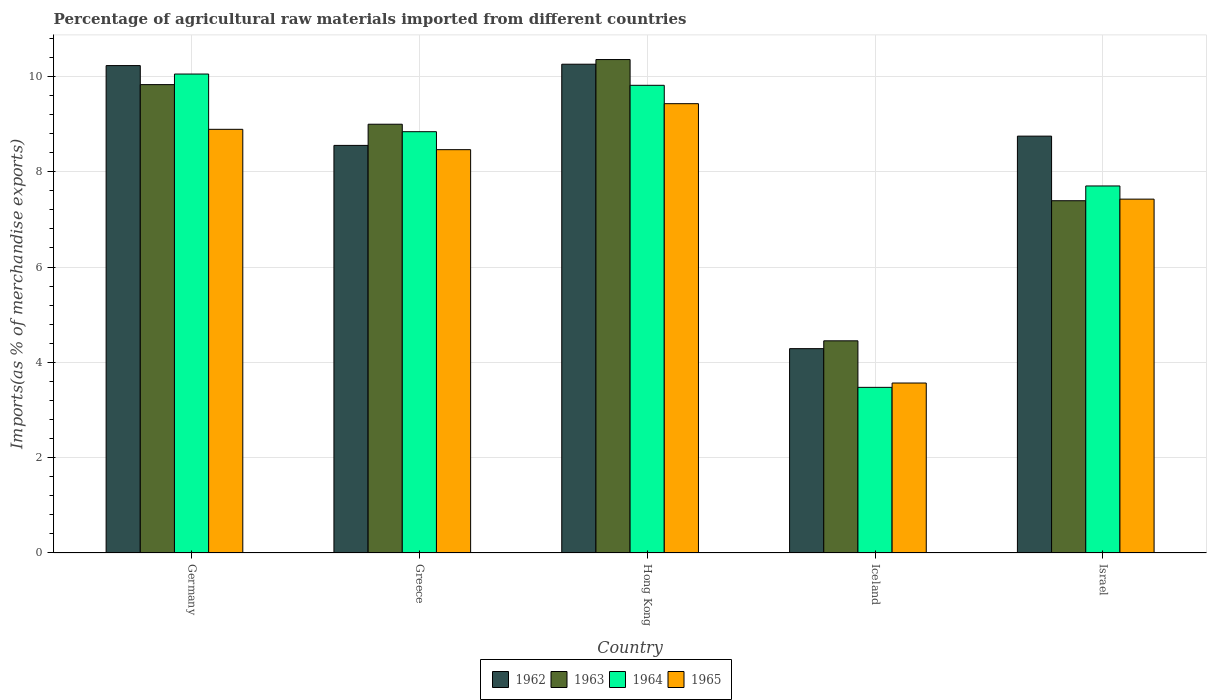How many different coloured bars are there?
Give a very brief answer. 4. How many groups of bars are there?
Give a very brief answer. 5. Are the number of bars per tick equal to the number of legend labels?
Provide a succinct answer. Yes. How many bars are there on the 4th tick from the right?
Make the answer very short. 4. What is the label of the 3rd group of bars from the left?
Offer a terse response. Hong Kong. In how many cases, is the number of bars for a given country not equal to the number of legend labels?
Your response must be concise. 0. What is the percentage of imports to different countries in 1962 in Greece?
Offer a very short reply. 8.55. Across all countries, what is the maximum percentage of imports to different countries in 1965?
Your response must be concise. 9.43. Across all countries, what is the minimum percentage of imports to different countries in 1963?
Offer a terse response. 4.45. In which country was the percentage of imports to different countries in 1965 maximum?
Your response must be concise. Hong Kong. What is the total percentage of imports to different countries in 1965 in the graph?
Your answer should be very brief. 37.77. What is the difference between the percentage of imports to different countries in 1965 in Germany and that in Israel?
Offer a terse response. 1.46. What is the difference between the percentage of imports to different countries in 1963 in Germany and the percentage of imports to different countries in 1965 in Israel?
Provide a short and direct response. 2.4. What is the average percentage of imports to different countries in 1965 per country?
Keep it short and to the point. 7.55. What is the difference between the percentage of imports to different countries of/in 1962 and percentage of imports to different countries of/in 1964 in Iceland?
Keep it short and to the point. 0.81. What is the ratio of the percentage of imports to different countries in 1963 in Hong Kong to that in Israel?
Offer a terse response. 1.4. What is the difference between the highest and the second highest percentage of imports to different countries in 1964?
Offer a very short reply. -0.97. What is the difference between the highest and the lowest percentage of imports to different countries in 1963?
Give a very brief answer. 5.9. Is it the case that in every country, the sum of the percentage of imports to different countries in 1964 and percentage of imports to different countries in 1965 is greater than the sum of percentage of imports to different countries in 1962 and percentage of imports to different countries in 1963?
Keep it short and to the point. No. What does the 3rd bar from the left in Greece represents?
Give a very brief answer. 1964. How many bars are there?
Provide a succinct answer. 20. Are all the bars in the graph horizontal?
Provide a succinct answer. No. Are the values on the major ticks of Y-axis written in scientific E-notation?
Ensure brevity in your answer.  No. Does the graph contain grids?
Offer a terse response. Yes. Where does the legend appear in the graph?
Ensure brevity in your answer.  Bottom center. What is the title of the graph?
Make the answer very short. Percentage of agricultural raw materials imported from different countries. Does "1991" appear as one of the legend labels in the graph?
Provide a short and direct response. No. What is the label or title of the Y-axis?
Your answer should be very brief. Imports(as % of merchandise exports). What is the Imports(as % of merchandise exports) of 1962 in Germany?
Give a very brief answer. 10.23. What is the Imports(as % of merchandise exports) of 1963 in Germany?
Offer a very short reply. 9.83. What is the Imports(as % of merchandise exports) of 1964 in Germany?
Your answer should be very brief. 10.05. What is the Imports(as % of merchandise exports) in 1965 in Germany?
Provide a short and direct response. 8.89. What is the Imports(as % of merchandise exports) of 1962 in Greece?
Provide a succinct answer. 8.55. What is the Imports(as % of merchandise exports) of 1963 in Greece?
Provide a short and direct response. 9. What is the Imports(as % of merchandise exports) of 1964 in Greece?
Make the answer very short. 8.84. What is the Imports(as % of merchandise exports) in 1965 in Greece?
Offer a terse response. 8.46. What is the Imports(as % of merchandise exports) of 1962 in Hong Kong?
Your answer should be very brief. 10.26. What is the Imports(as % of merchandise exports) in 1963 in Hong Kong?
Keep it short and to the point. 10.35. What is the Imports(as % of merchandise exports) of 1964 in Hong Kong?
Offer a terse response. 9.81. What is the Imports(as % of merchandise exports) in 1965 in Hong Kong?
Your answer should be very brief. 9.43. What is the Imports(as % of merchandise exports) in 1962 in Iceland?
Your answer should be compact. 4.29. What is the Imports(as % of merchandise exports) in 1963 in Iceland?
Give a very brief answer. 4.45. What is the Imports(as % of merchandise exports) in 1964 in Iceland?
Provide a short and direct response. 3.48. What is the Imports(as % of merchandise exports) in 1965 in Iceland?
Your answer should be very brief. 3.57. What is the Imports(as % of merchandise exports) of 1962 in Israel?
Your answer should be compact. 8.75. What is the Imports(as % of merchandise exports) in 1963 in Israel?
Give a very brief answer. 7.39. What is the Imports(as % of merchandise exports) of 1964 in Israel?
Make the answer very short. 7.7. What is the Imports(as % of merchandise exports) in 1965 in Israel?
Offer a terse response. 7.42. Across all countries, what is the maximum Imports(as % of merchandise exports) of 1962?
Make the answer very short. 10.26. Across all countries, what is the maximum Imports(as % of merchandise exports) of 1963?
Your answer should be compact. 10.35. Across all countries, what is the maximum Imports(as % of merchandise exports) in 1964?
Give a very brief answer. 10.05. Across all countries, what is the maximum Imports(as % of merchandise exports) in 1965?
Offer a very short reply. 9.43. Across all countries, what is the minimum Imports(as % of merchandise exports) of 1962?
Your answer should be compact. 4.29. Across all countries, what is the minimum Imports(as % of merchandise exports) of 1963?
Offer a terse response. 4.45. Across all countries, what is the minimum Imports(as % of merchandise exports) of 1964?
Your answer should be very brief. 3.48. Across all countries, what is the minimum Imports(as % of merchandise exports) in 1965?
Make the answer very short. 3.57. What is the total Imports(as % of merchandise exports) of 1962 in the graph?
Keep it short and to the point. 42.07. What is the total Imports(as % of merchandise exports) in 1963 in the graph?
Ensure brevity in your answer.  41.02. What is the total Imports(as % of merchandise exports) of 1964 in the graph?
Keep it short and to the point. 39.88. What is the total Imports(as % of merchandise exports) of 1965 in the graph?
Give a very brief answer. 37.77. What is the difference between the Imports(as % of merchandise exports) of 1962 in Germany and that in Greece?
Make the answer very short. 1.67. What is the difference between the Imports(as % of merchandise exports) of 1963 in Germany and that in Greece?
Your response must be concise. 0.83. What is the difference between the Imports(as % of merchandise exports) of 1964 in Germany and that in Greece?
Your response must be concise. 1.21. What is the difference between the Imports(as % of merchandise exports) of 1965 in Germany and that in Greece?
Offer a terse response. 0.43. What is the difference between the Imports(as % of merchandise exports) of 1962 in Germany and that in Hong Kong?
Give a very brief answer. -0.03. What is the difference between the Imports(as % of merchandise exports) of 1963 in Germany and that in Hong Kong?
Make the answer very short. -0.53. What is the difference between the Imports(as % of merchandise exports) in 1964 in Germany and that in Hong Kong?
Your response must be concise. 0.24. What is the difference between the Imports(as % of merchandise exports) of 1965 in Germany and that in Hong Kong?
Offer a terse response. -0.54. What is the difference between the Imports(as % of merchandise exports) in 1962 in Germany and that in Iceland?
Offer a very short reply. 5.94. What is the difference between the Imports(as % of merchandise exports) of 1963 in Germany and that in Iceland?
Offer a very short reply. 5.38. What is the difference between the Imports(as % of merchandise exports) of 1964 in Germany and that in Iceland?
Make the answer very short. 6.57. What is the difference between the Imports(as % of merchandise exports) of 1965 in Germany and that in Iceland?
Ensure brevity in your answer.  5.32. What is the difference between the Imports(as % of merchandise exports) of 1962 in Germany and that in Israel?
Provide a succinct answer. 1.48. What is the difference between the Imports(as % of merchandise exports) of 1963 in Germany and that in Israel?
Offer a very short reply. 2.44. What is the difference between the Imports(as % of merchandise exports) in 1964 in Germany and that in Israel?
Provide a succinct answer. 2.35. What is the difference between the Imports(as % of merchandise exports) in 1965 in Germany and that in Israel?
Your answer should be very brief. 1.46. What is the difference between the Imports(as % of merchandise exports) of 1962 in Greece and that in Hong Kong?
Your response must be concise. -1.7. What is the difference between the Imports(as % of merchandise exports) in 1963 in Greece and that in Hong Kong?
Offer a terse response. -1.36. What is the difference between the Imports(as % of merchandise exports) in 1964 in Greece and that in Hong Kong?
Your answer should be compact. -0.97. What is the difference between the Imports(as % of merchandise exports) in 1965 in Greece and that in Hong Kong?
Your answer should be compact. -0.96. What is the difference between the Imports(as % of merchandise exports) in 1962 in Greece and that in Iceland?
Ensure brevity in your answer.  4.26. What is the difference between the Imports(as % of merchandise exports) in 1963 in Greece and that in Iceland?
Keep it short and to the point. 4.54. What is the difference between the Imports(as % of merchandise exports) of 1964 in Greece and that in Iceland?
Your answer should be compact. 5.36. What is the difference between the Imports(as % of merchandise exports) of 1965 in Greece and that in Iceland?
Give a very brief answer. 4.9. What is the difference between the Imports(as % of merchandise exports) of 1962 in Greece and that in Israel?
Your answer should be very brief. -0.19. What is the difference between the Imports(as % of merchandise exports) in 1963 in Greece and that in Israel?
Provide a short and direct response. 1.6. What is the difference between the Imports(as % of merchandise exports) in 1964 in Greece and that in Israel?
Provide a succinct answer. 1.14. What is the difference between the Imports(as % of merchandise exports) in 1965 in Greece and that in Israel?
Your answer should be compact. 1.04. What is the difference between the Imports(as % of merchandise exports) of 1962 in Hong Kong and that in Iceland?
Provide a short and direct response. 5.97. What is the difference between the Imports(as % of merchandise exports) of 1963 in Hong Kong and that in Iceland?
Make the answer very short. 5.9. What is the difference between the Imports(as % of merchandise exports) of 1964 in Hong Kong and that in Iceland?
Your answer should be compact. 6.34. What is the difference between the Imports(as % of merchandise exports) in 1965 in Hong Kong and that in Iceland?
Give a very brief answer. 5.86. What is the difference between the Imports(as % of merchandise exports) in 1962 in Hong Kong and that in Israel?
Your answer should be very brief. 1.51. What is the difference between the Imports(as % of merchandise exports) in 1963 in Hong Kong and that in Israel?
Your answer should be compact. 2.96. What is the difference between the Imports(as % of merchandise exports) in 1964 in Hong Kong and that in Israel?
Offer a very short reply. 2.11. What is the difference between the Imports(as % of merchandise exports) of 1965 in Hong Kong and that in Israel?
Make the answer very short. 2. What is the difference between the Imports(as % of merchandise exports) of 1962 in Iceland and that in Israel?
Provide a short and direct response. -4.46. What is the difference between the Imports(as % of merchandise exports) of 1963 in Iceland and that in Israel?
Your answer should be compact. -2.94. What is the difference between the Imports(as % of merchandise exports) in 1964 in Iceland and that in Israel?
Offer a terse response. -4.23. What is the difference between the Imports(as % of merchandise exports) of 1965 in Iceland and that in Israel?
Provide a succinct answer. -3.86. What is the difference between the Imports(as % of merchandise exports) of 1962 in Germany and the Imports(as % of merchandise exports) of 1963 in Greece?
Your response must be concise. 1.23. What is the difference between the Imports(as % of merchandise exports) of 1962 in Germany and the Imports(as % of merchandise exports) of 1964 in Greece?
Make the answer very short. 1.39. What is the difference between the Imports(as % of merchandise exports) in 1962 in Germany and the Imports(as % of merchandise exports) in 1965 in Greece?
Your answer should be compact. 1.76. What is the difference between the Imports(as % of merchandise exports) of 1963 in Germany and the Imports(as % of merchandise exports) of 1964 in Greece?
Ensure brevity in your answer.  0.99. What is the difference between the Imports(as % of merchandise exports) in 1963 in Germany and the Imports(as % of merchandise exports) in 1965 in Greece?
Make the answer very short. 1.36. What is the difference between the Imports(as % of merchandise exports) of 1964 in Germany and the Imports(as % of merchandise exports) of 1965 in Greece?
Make the answer very short. 1.59. What is the difference between the Imports(as % of merchandise exports) of 1962 in Germany and the Imports(as % of merchandise exports) of 1963 in Hong Kong?
Your answer should be very brief. -0.13. What is the difference between the Imports(as % of merchandise exports) in 1962 in Germany and the Imports(as % of merchandise exports) in 1964 in Hong Kong?
Offer a very short reply. 0.41. What is the difference between the Imports(as % of merchandise exports) of 1962 in Germany and the Imports(as % of merchandise exports) of 1965 in Hong Kong?
Offer a terse response. 0.8. What is the difference between the Imports(as % of merchandise exports) in 1963 in Germany and the Imports(as % of merchandise exports) in 1964 in Hong Kong?
Give a very brief answer. 0.01. What is the difference between the Imports(as % of merchandise exports) of 1963 in Germany and the Imports(as % of merchandise exports) of 1965 in Hong Kong?
Provide a succinct answer. 0.4. What is the difference between the Imports(as % of merchandise exports) of 1964 in Germany and the Imports(as % of merchandise exports) of 1965 in Hong Kong?
Your response must be concise. 0.62. What is the difference between the Imports(as % of merchandise exports) of 1962 in Germany and the Imports(as % of merchandise exports) of 1963 in Iceland?
Your response must be concise. 5.77. What is the difference between the Imports(as % of merchandise exports) of 1962 in Germany and the Imports(as % of merchandise exports) of 1964 in Iceland?
Your answer should be compact. 6.75. What is the difference between the Imports(as % of merchandise exports) in 1962 in Germany and the Imports(as % of merchandise exports) in 1965 in Iceland?
Make the answer very short. 6.66. What is the difference between the Imports(as % of merchandise exports) of 1963 in Germany and the Imports(as % of merchandise exports) of 1964 in Iceland?
Offer a terse response. 6.35. What is the difference between the Imports(as % of merchandise exports) in 1963 in Germany and the Imports(as % of merchandise exports) in 1965 in Iceland?
Your answer should be very brief. 6.26. What is the difference between the Imports(as % of merchandise exports) of 1964 in Germany and the Imports(as % of merchandise exports) of 1965 in Iceland?
Your response must be concise. 6.48. What is the difference between the Imports(as % of merchandise exports) of 1962 in Germany and the Imports(as % of merchandise exports) of 1963 in Israel?
Offer a terse response. 2.84. What is the difference between the Imports(as % of merchandise exports) of 1962 in Germany and the Imports(as % of merchandise exports) of 1964 in Israel?
Make the answer very short. 2.53. What is the difference between the Imports(as % of merchandise exports) of 1962 in Germany and the Imports(as % of merchandise exports) of 1965 in Israel?
Make the answer very short. 2.8. What is the difference between the Imports(as % of merchandise exports) in 1963 in Germany and the Imports(as % of merchandise exports) in 1964 in Israel?
Give a very brief answer. 2.13. What is the difference between the Imports(as % of merchandise exports) in 1963 in Germany and the Imports(as % of merchandise exports) in 1965 in Israel?
Your answer should be compact. 2.4. What is the difference between the Imports(as % of merchandise exports) of 1964 in Germany and the Imports(as % of merchandise exports) of 1965 in Israel?
Offer a terse response. 2.62. What is the difference between the Imports(as % of merchandise exports) in 1962 in Greece and the Imports(as % of merchandise exports) in 1963 in Hong Kong?
Make the answer very short. -1.8. What is the difference between the Imports(as % of merchandise exports) in 1962 in Greece and the Imports(as % of merchandise exports) in 1964 in Hong Kong?
Offer a terse response. -1.26. What is the difference between the Imports(as % of merchandise exports) in 1962 in Greece and the Imports(as % of merchandise exports) in 1965 in Hong Kong?
Make the answer very short. -0.88. What is the difference between the Imports(as % of merchandise exports) of 1963 in Greece and the Imports(as % of merchandise exports) of 1964 in Hong Kong?
Provide a succinct answer. -0.82. What is the difference between the Imports(as % of merchandise exports) of 1963 in Greece and the Imports(as % of merchandise exports) of 1965 in Hong Kong?
Your answer should be compact. -0.43. What is the difference between the Imports(as % of merchandise exports) in 1964 in Greece and the Imports(as % of merchandise exports) in 1965 in Hong Kong?
Ensure brevity in your answer.  -0.59. What is the difference between the Imports(as % of merchandise exports) of 1962 in Greece and the Imports(as % of merchandise exports) of 1963 in Iceland?
Your response must be concise. 4.1. What is the difference between the Imports(as % of merchandise exports) in 1962 in Greece and the Imports(as % of merchandise exports) in 1964 in Iceland?
Ensure brevity in your answer.  5.08. What is the difference between the Imports(as % of merchandise exports) of 1962 in Greece and the Imports(as % of merchandise exports) of 1965 in Iceland?
Offer a terse response. 4.99. What is the difference between the Imports(as % of merchandise exports) of 1963 in Greece and the Imports(as % of merchandise exports) of 1964 in Iceland?
Your response must be concise. 5.52. What is the difference between the Imports(as % of merchandise exports) in 1963 in Greece and the Imports(as % of merchandise exports) in 1965 in Iceland?
Provide a succinct answer. 5.43. What is the difference between the Imports(as % of merchandise exports) in 1964 in Greece and the Imports(as % of merchandise exports) in 1965 in Iceland?
Your answer should be compact. 5.27. What is the difference between the Imports(as % of merchandise exports) of 1962 in Greece and the Imports(as % of merchandise exports) of 1963 in Israel?
Give a very brief answer. 1.16. What is the difference between the Imports(as % of merchandise exports) of 1962 in Greece and the Imports(as % of merchandise exports) of 1964 in Israel?
Provide a succinct answer. 0.85. What is the difference between the Imports(as % of merchandise exports) of 1962 in Greece and the Imports(as % of merchandise exports) of 1965 in Israel?
Give a very brief answer. 1.13. What is the difference between the Imports(as % of merchandise exports) of 1963 in Greece and the Imports(as % of merchandise exports) of 1964 in Israel?
Make the answer very short. 1.3. What is the difference between the Imports(as % of merchandise exports) of 1963 in Greece and the Imports(as % of merchandise exports) of 1965 in Israel?
Your answer should be very brief. 1.57. What is the difference between the Imports(as % of merchandise exports) in 1964 in Greece and the Imports(as % of merchandise exports) in 1965 in Israel?
Your answer should be compact. 1.42. What is the difference between the Imports(as % of merchandise exports) of 1962 in Hong Kong and the Imports(as % of merchandise exports) of 1963 in Iceland?
Ensure brevity in your answer.  5.8. What is the difference between the Imports(as % of merchandise exports) in 1962 in Hong Kong and the Imports(as % of merchandise exports) in 1964 in Iceland?
Your answer should be compact. 6.78. What is the difference between the Imports(as % of merchandise exports) in 1962 in Hong Kong and the Imports(as % of merchandise exports) in 1965 in Iceland?
Provide a succinct answer. 6.69. What is the difference between the Imports(as % of merchandise exports) of 1963 in Hong Kong and the Imports(as % of merchandise exports) of 1964 in Iceland?
Keep it short and to the point. 6.88. What is the difference between the Imports(as % of merchandise exports) of 1963 in Hong Kong and the Imports(as % of merchandise exports) of 1965 in Iceland?
Your response must be concise. 6.79. What is the difference between the Imports(as % of merchandise exports) in 1964 in Hong Kong and the Imports(as % of merchandise exports) in 1965 in Iceland?
Provide a short and direct response. 6.25. What is the difference between the Imports(as % of merchandise exports) of 1962 in Hong Kong and the Imports(as % of merchandise exports) of 1963 in Israel?
Keep it short and to the point. 2.86. What is the difference between the Imports(as % of merchandise exports) of 1962 in Hong Kong and the Imports(as % of merchandise exports) of 1964 in Israel?
Offer a terse response. 2.55. What is the difference between the Imports(as % of merchandise exports) in 1962 in Hong Kong and the Imports(as % of merchandise exports) in 1965 in Israel?
Your response must be concise. 2.83. What is the difference between the Imports(as % of merchandise exports) in 1963 in Hong Kong and the Imports(as % of merchandise exports) in 1964 in Israel?
Offer a terse response. 2.65. What is the difference between the Imports(as % of merchandise exports) in 1963 in Hong Kong and the Imports(as % of merchandise exports) in 1965 in Israel?
Keep it short and to the point. 2.93. What is the difference between the Imports(as % of merchandise exports) of 1964 in Hong Kong and the Imports(as % of merchandise exports) of 1965 in Israel?
Keep it short and to the point. 2.39. What is the difference between the Imports(as % of merchandise exports) in 1962 in Iceland and the Imports(as % of merchandise exports) in 1963 in Israel?
Ensure brevity in your answer.  -3.1. What is the difference between the Imports(as % of merchandise exports) in 1962 in Iceland and the Imports(as % of merchandise exports) in 1964 in Israel?
Provide a succinct answer. -3.41. What is the difference between the Imports(as % of merchandise exports) in 1962 in Iceland and the Imports(as % of merchandise exports) in 1965 in Israel?
Ensure brevity in your answer.  -3.14. What is the difference between the Imports(as % of merchandise exports) of 1963 in Iceland and the Imports(as % of merchandise exports) of 1964 in Israel?
Provide a succinct answer. -3.25. What is the difference between the Imports(as % of merchandise exports) of 1963 in Iceland and the Imports(as % of merchandise exports) of 1965 in Israel?
Keep it short and to the point. -2.97. What is the difference between the Imports(as % of merchandise exports) in 1964 in Iceland and the Imports(as % of merchandise exports) in 1965 in Israel?
Keep it short and to the point. -3.95. What is the average Imports(as % of merchandise exports) of 1962 per country?
Offer a terse response. 8.41. What is the average Imports(as % of merchandise exports) in 1963 per country?
Ensure brevity in your answer.  8.2. What is the average Imports(as % of merchandise exports) in 1964 per country?
Provide a short and direct response. 7.98. What is the average Imports(as % of merchandise exports) of 1965 per country?
Offer a terse response. 7.55. What is the difference between the Imports(as % of merchandise exports) in 1962 and Imports(as % of merchandise exports) in 1963 in Germany?
Your answer should be compact. 0.4. What is the difference between the Imports(as % of merchandise exports) of 1962 and Imports(as % of merchandise exports) of 1964 in Germany?
Ensure brevity in your answer.  0.18. What is the difference between the Imports(as % of merchandise exports) of 1962 and Imports(as % of merchandise exports) of 1965 in Germany?
Your answer should be very brief. 1.34. What is the difference between the Imports(as % of merchandise exports) in 1963 and Imports(as % of merchandise exports) in 1964 in Germany?
Your answer should be very brief. -0.22. What is the difference between the Imports(as % of merchandise exports) of 1963 and Imports(as % of merchandise exports) of 1965 in Germany?
Your answer should be very brief. 0.94. What is the difference between the Imports(as % of merchandise exports) of 1964 and Imports(as % of merchandise exports) of 1965 in Germany?
Your answer should be compact. 1.16. What is the difference between the Imports(as % of merchandise exports) in 1962 and Imports(as % of merchandise exports) in 1963 in Greece?
Give a very brief answer. -0.44. What is the difference between the Imports(as % of merchandise exports) in 1962 and Imports(as % of merchandise exports) in 1964 in Greece?
Offer a terse response. -0.29. What is the difference between the Imports(as % of merchandise exports) of 1962 and Imports(as % of merchandise exports) of 1965 in Greece?
Ensure brevity in your answer.  0.09. What is the difference between the Imports(as % of merchandise exports) of 1963 and Imports(as % of merchandise exports) of 1964 in Greece?
Provide a succinct answer. 0.16. What is the difference between the Imports(as % of merchandise exports) in 1963 and Imports(as % of merchandise exports) in 1965 in Greece?
Your answer should be very brief. 0.53. What is the difference between the Imports(as % of merchandise exports) in 1964 and Imports(as % of merchandise exports) in 1965 in Greece?
Offer a terse response. 0.38. What is the difference between the Imports(as % of merchandise exports) of 1962 and Imports(as % of merchandise exports) of 1963 in Hong Kong?
Give a very brief answer. -0.1. What is the difference between the Imports(as % of merchandise exports) of 1962 and Imports(as % of merchandise exports) of 1964 in Hong Kong?
Offer a terse response. 0.44. What is the difference between the Imports(as % of merchandise exports) in 1962 and Imports(as % of merchandise exports) in 1965 in Hong Kong?
Give a very brief answer. 0.83. What is the difference between the Imports(as % of merchandise exports) of 1963 and Imports(as % of merchandise exports) of 1964 in Hong Kong?
Make the answer very short. 0.54. What is the difference between the Imports(as % of merchandise exports) in 1963 and Imports(as % of merchandise exports) in 1965 in Hong Kong?
Ensure brevity in your answer.  0.93. What is the difference between the Imports(as % of merchandise exports) in 1964 and Imports(as % of merchandise exports) in 1965 in Hong Kong?
Provide a succinct answer. 0.39. What is the difference between the Imports(as % of merchandise exports) of 1962 and Imports(as % of merchandise exports) of 1963 in Iceland?
Provide a short and direct response. -0.16. What is the difference between the Imports(as % of merchandise exports) of 1962 and Imports(as % of merchandise exports) of 1964 in Iceland?
Keep it short and to the point. 0.81. What is the difference between the Imports(as % of merchandise exports) of 1962 and Imports(as % of merchandise exports) of 1965 in Iceland?
Ensure brevity in your answer.  0.72. What is the difference between the Imports(as % of merchandise exports) of 1963 and Imports(as % of merchandise exports) of 1964 in Iceland?
Your answer should be compact. 0.98. What is the difference between the Imports(as % of merchandise exports) of 1963 and Imports(as % of merchandise exports) of 1965 in Iceland?
Provide a succinct answer. 0.89. What is the difference between the Imports(as % of merchandise exports) in 1964 and Imports(as % of merchandise exports) in 1965 in Iceland?
Offer a very short reply. -0.09. What is the difference between the Imports(as % of merchandise exports) in 1962 and Imports(as % of merchandise exports) in 1963 in Israel?
Provide a short and direct response. 1.36. What is the difference between the Imports(as % of merchandise exports) of 1962 and Imports(as % of merchandise exports) of 1964 in Israel?
Offer a very short reply. 1.05. What is the difference between the Imports(as % of merchandise exports) of 1962 and Imports(as % of merchandise exports) of 1965 in Israel?
Make the answer very short. 1.32. What is the difference between the Imports(as % of merchandise exports) of 1963 and Imports(as % of merchandise exports) of 1964 in Israel?
Make the answer very short. -0.31. What is the difference between the Imports(as % of merchandise exports) in 1963 and Imports(as % of merchandise exports) in 1965 in Israel?
Provide a succinct answer. -0.03. What is the difference between the Imports(as % of merchandise exports) in 1964 and Imports(as % of merchandise exports) in 1965 in Israel?
Provide a short and direct response. 0.28. What is the ratio of the Imports(as % of merchandise exports) of 1962 in Germany to that in Greece?
Ensure brevity in your answer.  1.2. What is the ratio of the Imports(as % of merchandise exports) of 1963 in Germany to that in Greece?
Offer a very short reply. 1.09. What is the ratio of the Imports(as % of merchandise exports) of 1964 in Germany to that in Greece?
Offer a terse response. 1.14. What is the ratio of the Imports(as % of merchandise exports) in 1965 in Germany to that in Greece?
Your answer should be compact. 1.05. What is the ratio of the Imports(as % of merchandise exports) of 1962 in Germany to that in Hong Kong?
Offer a terse response. 1. What is the ratio of the Imports(as % of merchandise exports) of 1963 in Germany to that in Hong Kong?
Offer a very short reply. 0.95. What is the ratio of the Imports(as % of merchandise exports) of 1964 in Germany to that in Hong Kong?
Make the answer very short. 1.02. What is the ratio of the Imports(as % of merchandise exports) of 1965 in Germany to that in Hong Kong?
Ensure brevity in your answer.  0.94. What is the ratio of the Imports(as % of merchandise exports) of 1962 in Germany to that in Iceland?
Ensure brevity in your answer.  2.39. What is the ratio of the Imports(as % of merchandise exports) of 1963 in Germany to that in Iceland?
Your response must be concise. 2.21. What is the ratio of the Imports(as % of merchandise exports) in 1964 in Germany to that in Iceland?
Your answer should be compact. 2.89. What is the ratio of the Imports(as % of merchandise exports) in 1965 in Germany to that in Iceland?
Provide a succinct answer. 2.49. What is the ratio of the Imports(as % of merchandise exports) of 1962 in Germany to that in Israel?
Make the answer very short. 1.17. What is the ratio of the Imports(as % of merchandise exports) in 1963 in Germany to that in Israel?
Make the answer very short. 1.33. What is the ratio of the Imports(as % of merchandise exports) in 1964 in Germany to that in Israel?
Provide a succinct answer. 1.3. What is the ratio of the Imports(as % of merchandise exports) of 1965 in Germany to that in Israel?
Your answer should be compact. 1.2. What is the ratio of the Imports(as % of merchandise exports) in 1962 in Greece to that in Hong Kong?
Provide a succinct answer. 0.83. What is the ratio of the Imports(as % of merchandise exports) in 1963 in Greece to that in Hong Kong?
Your answer should be compact. 0.87. What is the ratio of the Imports(as % of merchandise exports) in 1964 in Greece to that in Hong Kong?
Make the answer very short. 0.9. What is the ratio of the Imports(as % of merchandise exports) in 1965 in Greece to that in Hong Kong?
Provide a succinct answer. 0.9. What is the ratio of the Imports(as % of merchandise exports) in 1962 in Greece to that in Iceland?
Keep it short and to the point. 1.99. What is the ratio of the Imports(as % of merchandise exports) in 1963 in Greece to that in Iceland?
Provide a succinct answer. 2.02. What is the ratio of the Imports(as % of merchandise exports) of 1964 in Greece to that in Iceland?
Provide a short and direct response. 2.54. What is the ratio of the Imports(as % of merchandise exports) of 1965 in Greece to that in Iceland?
Your answer should be very brief. 2.37. What is the ratio of the Imports(as % of merchandise exports) of 1962 in Greece to that in Israel?
Provide a succinct answer. 0.98. What is the ratio of the Imports(as % of merchandise exports) in 1963 in Greece to that in Israel?
Provide a succinct answer. 1.22. What is the ratio of the Imports(as % of merchandise exports) of 1964 in Greece to that in Israel?
Keep it short and to the point. 1.15. What is the ratio of the Imports(as % of merchandise exports) in 1965 in Greece to that in Israel?
Offer a terse response. 1.14. What is the ratio of the Imports(as % of merchandise exports) of 1962 in Hong Kong to that in Iceland?
Your answer should be compact. 2.39. What is the ratio of the Imports(as % of merchandise exports) of 1963 in Hong Kong to that in Iceland?
Provide a succinct answer. 2.33. What is the ratio of the Imports(as % of merchandise exports) in 1964 in Hong Kong to that in Iceland?
Offer a very short reply. 2.82. What is the ratio of the Imports(as % of merchandise exports) of 1965 in Hong Kong to that in Iceland?
Ensure brevity in your answer.  2.64. What is the ratio of the Imports(as % of merchandise exports) of 1962 in Hong Kong to that in Israel?
Your answer should be very brief. 1.17. What is the ratio of the Imports(as % of merchandise exports) of 1963 in Hong Kong to that in Israel?
Provide a short and direct response. 1.4. What is the ratio of the Imports(as % of merchandise exports) of 1964 in Hong Kong to that in Israel?
Keep it short and to the point. 1.27. What is the ratio of the Imports(as % of merchandise exports) in 1965 in Hong Kong to that in Israel?
Your response must be concise. 1.27. What is the ratio of the Imports(as % of merchandise exports) of 1962 in Iceland to that in Israel?
Give a very brief answer. 0.49. What is the ratio of the Imports(as % of merchandise exports) in 1963 in Iceland to that in Israel?
Give a very brief answer. 0.6. What is the ratio of the Imports(as % of merchandise exports) of 1964 in Iceland to that in Israel?
Offer a terse response. 0.45. What is the ratio of the Imports(as % of merchandise exports) in 1965 in Iceland to that in Israel?
Provide a short and direct response. 0.48. What is the difference between the highest and the second highest Imports(as % of merchandise exports) of 1962?
Provide a succinct answer. 0.03. What is the difference between the highest and the second highest Imports(as % of merchandise exports) of 1963?
Give a very brief answer. 0.53. What is the difference between the highest and the second highest Imports(as % of merchandise exports) of 1964?
Offer a very short reply. 0.24. What is the difference between the highest and the second highest Imports(as % of merchandise exports) in 1965?
Make the answer very short. 0.54. What is the difference between the highest and the lowest Imports(as % of merchandise exports) of 1962?
Your answer should be compact. 5.97. What is the difference between the highest and the lowest Imports(as % of merchandise exports) in 1963?
Your answer should be compact. 5.9. What is the difference between the highest and the lowest Imports(as % of merchandise exports) in 1964?
Offer a terse response. 6.57. What is the difference between the highest and the lowest Imports(as % of merchandise exports) in 1965?
Keep it short and to the point. 5.86. 